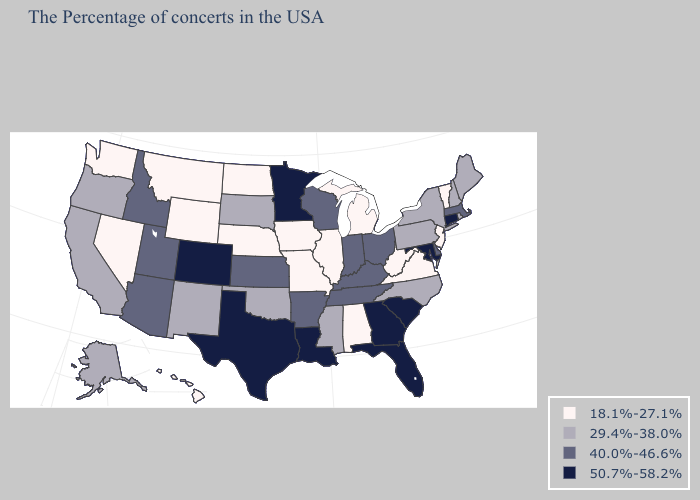Does Virginia have the lowest value in the USA?
Quick response, please. Yes. Which states have the lowest value in the South?
Write a very short answer. Virginia, West Virginia, Alabama. Is the legend a continuous bar?
Give a very brief answer. No. Does Georgia have the same value as Nevada?
Answer briefly. No. How many symbols are there in the legend?
Short answer required. 4. What is the highest value in the USA?
Short answer required. 50.7%-58.2%. Does West Virginia have the highest value in the USA?
Quick response, please. No. Name the states that have a value in the range 50.7%-58.2%?
Keep it brief. Connecticut, Maryland, South Carolina, Florida, Georgia, Louisiana, Minnesota, Texas, Colorado. Which states have the lowest value in the USA?
Write a very short answer. Vermont, New Jersey, Virginia, West Virginia, Michigan, Alabama, Illinois, Missouri, Iowa, Nebraska, North Dakota, Wyoming, Montana, Nevada, Washington, Hawaii. Is the legend a continuous bar?
Keep it brief. No. What is the value of West Virginia?
Write a very short answer. 18.1%-27.1%. Does Idaho have the lowest value in the West?
Be succinct. No. What is the value of Connecticut?
Concise answer only. 50.7%-58.2%. What is the highest value in the USA?
Keep it brief. 50.7%-58.2%. What is the lowest value in states that border New Hampshire?
Concise answer only. 18.1%-27.1%. 